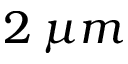Convert formula to latex. <formula><loc_0><loc_0><loc_500><loc_500>2 \, \mu m</formula> 